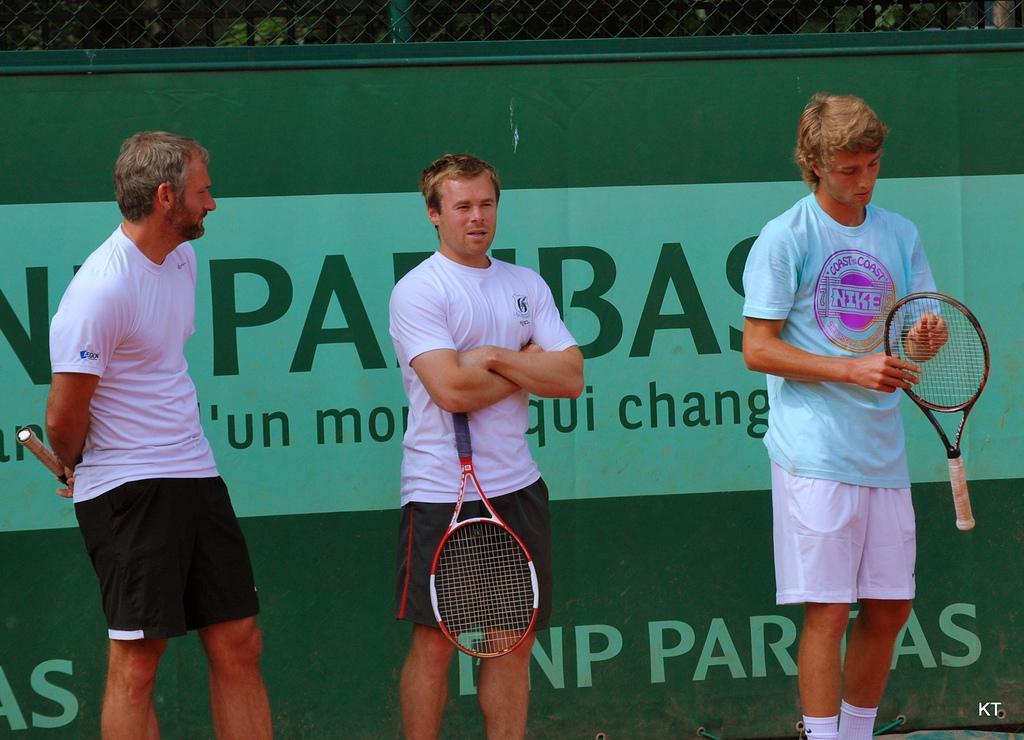How many rackets are there?
Give a very brief answer. 3. How many men are wearing white shirts?
Give a very brief answer. 2. How many men are wearing shorts?
Give a very brief answer. 3. How many men have a beard?
Give a very brief answer. 1. How many men are wearing white socks?
Give a very brief answer. 1. How many men are shown?
Give a very brief answer. 3. How many people are pictured?
Give a very brief answer. 3. How many guys are there?
Give a very brief answer. 3. 